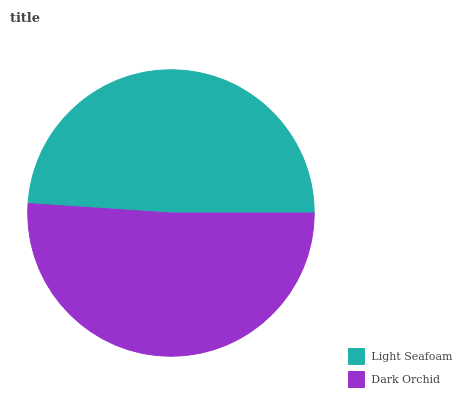Is Light Seafoam the minimum?
Answer yes or no. Yes. Is Dark Orchid the maximum?
Answer yes or no. Yes. Is Dark Orchid the minimum?
Answer yes or no. No. Is Dark Orchid greater than Light Seafoam?
Answer yes or no. Yes. Is Light Seafoam less than Dark Orchid?
Answer yes or no. Yes. Is Light Seafoam greater than Dark Orchid?
Answer yes or no. No. Is Dark Orchid less than Light Seafoam?
Answer yes or no. No. Is Dark Orchid the high median?
Answer yes or no. Yes. Is Light Seafoam the low median?
Answer yes or no. Yes. Is Light Seafoam the high median?
Answer yes or no. No. Is Dark Orchid the low median?
Answer yes or no. No. 